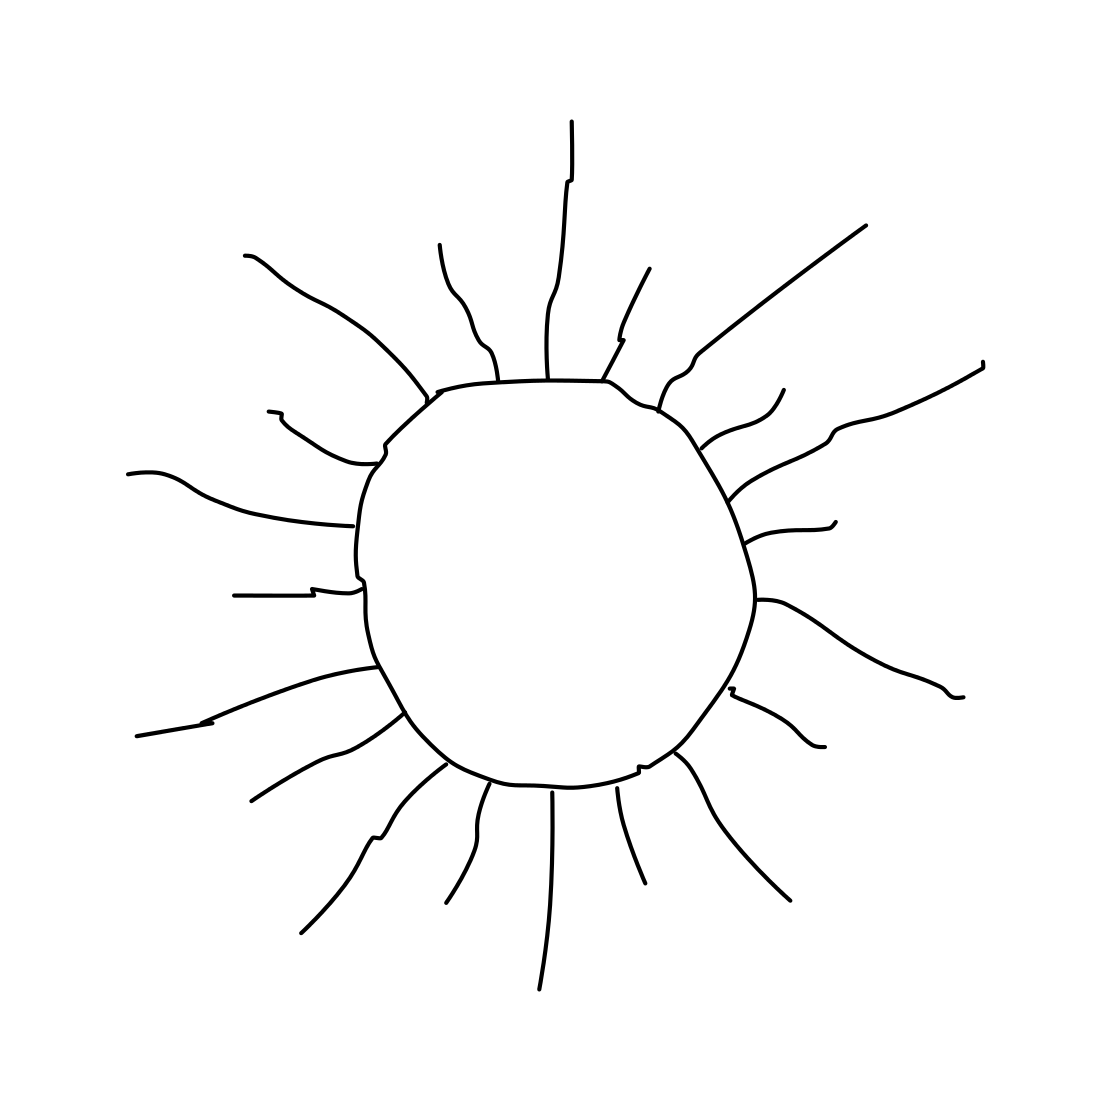Can you tell me what time of day this image could represent? The image of the sun with its prominent rays generally suggests it's depicting daytime, likely noon when the sun is at its highest and brightest. 